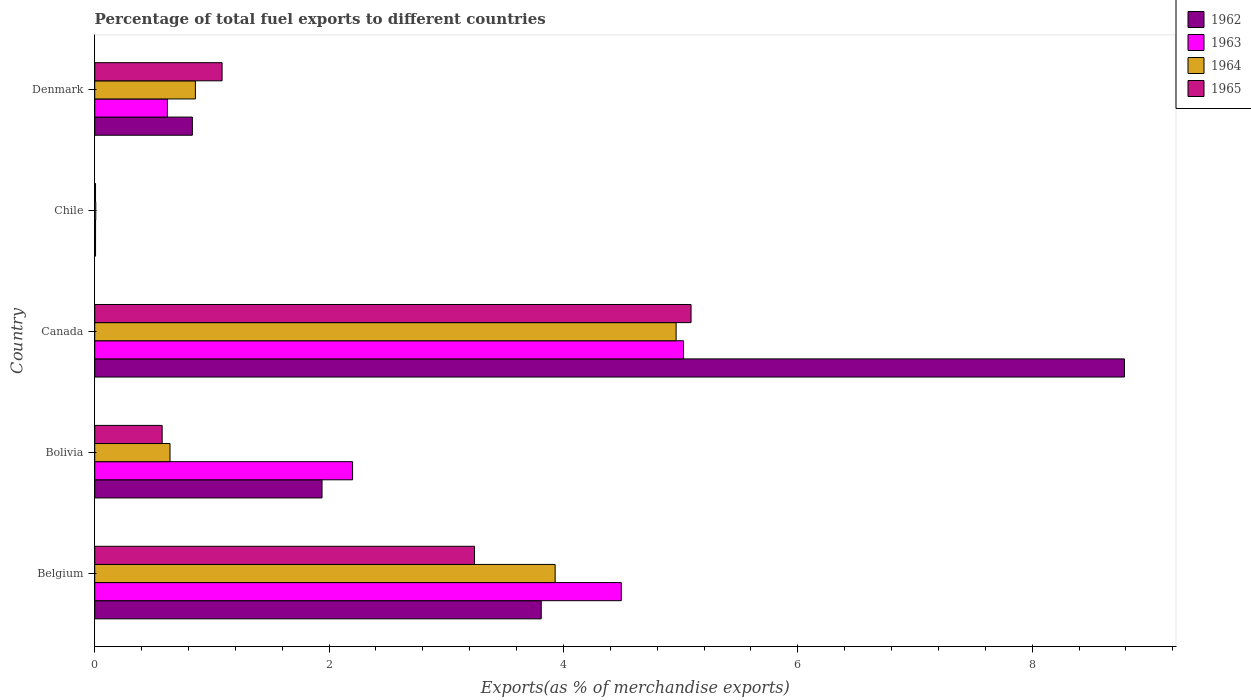How many bars are there on the 3rd tick from the bottom?
Provide a succinct answer. 4. What is the label of the 5th group of bars from the top?
Your answer should be compact. Belgium. What is the percentage of exports to different countries in 1963 in Canada?
Ensure brevity in your answer.  5.02. Across all countries, what is the maximum percentage of exports to different countries in 1964?
Give a very brief answer. 4.96. Across all countries, what is the minimum percentage of exports to different countries in 1965?
Offer a terse response. 0.01. In which country was the percentage of exports to different countries in 1962 maximum?
Offer a very short reply. Canada. In which country was the percentage of exports to different countries in 1964 minimum?
Ensure brevity in your answer.  Chile. What is the total percentage of exports to different countries in 1964 in the graph?
Your answer should be very brief. 10.4. What is the difference between the percentage of exports to different countries in 1962 in Chile and that in Denmark?
Offer a very short reply. -0.83. What is the difference between the percentage of exports to different countries in 1964 in Belgium and the percentage of exports to different countries in 1962 in Canada?
Provide a succinct answer. -4.86. What is the average percentage of exports to different countries in 1965 per country?
Your answer should be compact. 2. What is the difference between the percentage of exports to different countries in 1964 and percentage of exports to different countries in 1962 in Canada?
Your answer should be compact. -3.83. In how many countries, is the percentage of exports to different countries in 1965 greater than 6 %?
Your response must be concise. 0. What is the ratio of the percentage of exports to different countries in 1964 in Bolivia to that in Chile?
Your answer should be compact. 71.92. Is the percentage of exports to different countries in 1963 in Belgium less than that in Chile?
Offer a terse response. No. Is the difference between the percentage of exports to different countries in 1964 in Canada and Chile greater than the difference between the percentage of exports to different countries in 1962 in Canada and Chile?
Your answer should be compact. No. What is the difference between the highest and the second highest percentage of exports to different countries in 1963?
Give a very brief answer. 0.53. What is the difference between the highest and the lowest percentage of exports to different countries in 1962?
Your answer should be very brief. 8.78. In how many countries, is the percentage of exports to different countries in 1963 greater than the average percentage of exports to different countries in 1963 taken over all countries?
Make the answer very short. 2. Is it the case that in every country, the sum of the percentage of exports to different countries in 1964 and percentage of exports to different countries in 1962 is greater than the sum of percentage of exports to different countries in 1963 and percentage of exports to different countries in 1965?
Provide a succinct answer. No. What does the 3rd bar from the top in Belgium represents?
Keep it short and to the point. 1963. What does the 3rd bar from the bottom in Chile represents?
Provide a succinct answer. 1964. How many bars are there?
Your answer should be compact. 20. How many countries are there in the graph?
Your answer should be very brief. 5. What is the difference between two consecutive major ticks on the X-axis?
Offer a very short reply. 2. Does the graph contain any zero values?
Offer a terse response. No. Does the graph contain grids?
Offer a very short reply. No. Where does the legend appear in the graph?
Ensure brevity in your answer.  Top right. How many legend labels are there?
Offer a very short reply. 4. What is the title of the graph?
Make the answer very short. Percentage of total fuel exports to different countries. Does "1995" appear as one of the legend labels in the graph?
Your answer should be compact. No. What is the label or title of the X-axis?
Provide a succinct answer. Exports(as % of merchandise exports). What is the label or title of the Y-axis?
Your answer should be very brief. Country. What is the Exports(as % of merchandise exports) in 1962 in Belgium?
Ensure brevity in your answer.  3.81. What is the Exports(as % of merchandise exports) in 1963 in Belgium?
Your answer should be very brief. 4.49. What is the Exports(as % of merchandise exports) of 1964 in Belgium?
Keep it short and to the point. 3.93. What is the Exports(as % of merchandise exports) of 1965 in Belgium?
Your response must be concise. 3.24. What is the Exports(as % of merchandise exports) of 1962 in Bolivia?
Provide a succinct answer. 1.94. What is the Exports(as % of merchandise exports) of 1963 in Bolivia?
Offer a very short reply. 2.2. What is the Exports(as % of merchandise exports) of 1964 in Bolivia?
Provide a short and direct response. 0.64. What is the Exports(as % of merchandise exports) in 1965 in Bolivia?
Provide a short and direct response. 0.58. What is the Exports(as % of merchandise exports) of 1962 in Canada?
Your answer should be compact. 8.79. What is the Exports(as % of merchandise exports) of 1963 in Canada?
Make the answer very short. 5.02. What is the Exports(as % of merchandise exports) of 1964 in Canada?
Give a very brief answer. 4.96. What is the Exports(as % of merchandise exports) of 1965 in Canada?
Give a very brief answer. 5.09. What is the Exports(as % of merchandise exports) in 1962 in Chile?
Your answer should be compact. 0.01. What is the Exports(as % of merchandise exports) of 1963 in Chile?
Keep it short and to the point. 0.01. What is the Exports(as % of merchandise exports) of 1964 in Chile?
Give a very brief answer. 0.01. What is the Exports(as % of merchandise exports) of 1965 in Chile?
Your answer should be compact. 0.01. What is the Exports(as % of merchandise exports) of 1962 in Denmark?
Your answer should be compact. 0.83. What is the Exports(as % of merchandise exports) in 1963 in Denmark?
Offer a very short reply. 0.62. What is the Exports(as % of merchandise exports) of 1964 in Denmark?
Your answer should be compact. 0.86. What is the Exports(as % of merchandise exports) in 1965 in Denmark?
Your response must be concise. 1.09. Across all countries, what is the maximum Exports(as % of merchandise exports) of 1962?
Make the answer very short. 8.79. Across all countries, what is the maximum Exports(as % of merchandise exports) in 1963?
Your answer should be compact. 5.02. Across all countries, what is the maximum Exports(as % of merchandise exports) in 1964?
Your answer should be compact. 4.96. Across all countries, what is the maximum Exports(as % of merchandise exports) of 1965?
Make the answer very short. 5.09. Across all countries, what is the minimum Exports(as % of merchandise exports) of 1962?
Provide a short and direct response. 0.01. Across all countries, what is the minimum Exports(as % of merchandise exports) in 1963?
Make the answer very short. 0.01. Across all countries, what is the minimum Exports(as % of merchandise exports) of 1964?
Provide a succinct answer. 0.01. Across all countries, what is the minimum Exports(as % of merchandise exports) in 1965?
Your response must be concise. 0.01. What is the total Exports(as % of merchandise exports) of 1962 in the graph?
Offer a very short reply. 15.38. What is the total Exports(as % of merchandise exports) in 1963 in the graph?
Give a very brief answer. 12.35. What is the total Exports(as % of merchandise exports) of 1964 in the graph?
Keep it short and to the point. 10.4. What is the total Exports(as % of merchandise exports) of 1965 in the graph?
Make the answer very short. 10. What is the difference between the Exports(as % of merchandise exports) of 1962 in Belgium and that in Bolivia?
Give a very brief answer. 1.87. What is the difference between the Exports(as % of merchandise exports) of 1963 in Belgium and that in Bolivia?
Ensure brevity in your answer.  2.29. What is the difference between the Exports(as % of merchandise exports) of 1964 in Belgium and that in Bolivia?
Make the answer very short. 3.29. What is the difference between the Exports(as % of merchandise exports) of 1965 in Belgium and that in Bolivia?
Your response must be concise. 2.67. What is the difference between the Exports(as % of merchandise exports) in 1962 in Belgium and that in Canada?
Offer a terse response. -4.98. What is the difference between the Exports(as % of merchandise exports) in 1963 in Belgium and that in Canada?
Your answer should be compact. -0.53. What is the difference between the Exports(as % of merchandise exports) in 1964 in Belgium and that in Canada?
Offer a terse response. -1.03. What is the difference between the Exports(as % of merchandise exports) of 1965 in Belgium and that in Canada?
Keep it short and to the point. -1.85. What is the difference between the Exports(as % of merchandise exports) of 1962 in Belgium and that in Chile?
Give a very brief answer. 3.8. What is the difference between the Exports(as % of merchandise exports) of 1963 in Belgium and that in Chile?
Your answer should be compact. 4.49. What is the difference between the Exports(as % of merchandise exports) in 1964 in Belgium and that in Chile?
Ensure brevity in your answer.  3.92. What is the difference between the Exports(as % of merchandise exports) in 1965 in Belgium and that in Chile?
Make the answer very short. 3.23. What is the difference between the Exports(as % of merchandise exports) in 1962 in Belgium and that in Denmark?
Keep it short and to the point. 2.98. What is the difference between the Exports(as % of merchandise exports) in 1963 in Belgium and that in Denmark?
Keep it short and to the point. 3.87. What is the difference between the Exports(as % of merchandise exports) of 1964 in Belgium and that in Denmark?
Ensure brevity in your answer.  3.07. What is the difference between the Exports(as % of merchandise exports) in 1965 in Belgium and that in Denmark?
Give a very brief answer. 2.15. What is the difference between the Exports(as % of merchandise exports) of 1962 in Bolivia and that in Canada?
Your response must be concise. -6.85. What is the difference between the Exports(as % of merchandise exports) in 1963 in Bolivia and that in Canada?
Your answer should be compact. -2.82. What is the difference between the Exports(as % of merchandise exports) of 1964 in Bolivia and that in Canada?
Give a very brief answer. -4.32. What is the difference between the Exports(as % of merchandise exports) in 1965 in Bolivia and that in Canada?
Your answer should be very brief. -4.51. What is the difference between the Exports(as % of merchandise exports) of 1962 in Bolivia and that in Chile?
Ensure brevity in your answer.  1.93. What is the difference between the Exports(as % of merchandise exports) of 1963 in Bolivia and that in Chile?
Make the answer very short. 2.19. What is the difference between the Exports(as % of merchandise exports) in 1964 in Bolivia and that in Chile?
Offer a terse response. 0.63. What is the difference between the Exports(as % of merchandise exports) in 1965 in Bolivia and that in Chile?
Give a very brief answer. 0.57. What is the difference between the Exports(as % of merchandise exports) in 1962 in Bolivia and that in Denmark?
Ensure brevity in your answer.  1.11. What is the difference between the Exports(as % of merchandise exports) in 1963 in Bolivia and that in Denmark?
Your answer should be very brief. 1.58. What is the difference between the Exports(as % of merchandise exports) of 1964 in Bolivia and that in Denmark?
Provide a short and direct response. -0.22. What is the difference between the Exports(as % of merchandise exports) in 1965 in Bolivia and that in Denmark?
Offer a very short reply. -0.51. What is the difference between the Exports(as % of merchandise exports) in 1962 in Canada and that in Chile?
Your answer should be very brief. 8.78. What is the difference between the Exports(as % of merchandise exports) in 1963 in Canada and that in Chile?
Provide a short and direct response. 5.02. What is the difference between the Exports(as % of merchandise exports) in 1964 in Canada and that in Chile?
Ensure brevity in your answer.  4.95. What is the difference between the Exports(as % of merchandise exports) of 1965 in Canada and that in Chile?
Your answer should be compact. 5.08. What is the difference between the Exports(as % of merchandise exports) of 1962 in Canada and that in Denmark?
Make the answer very short. 7.95. What is the difference between the Exports(as % of merchandise exports) in 1963 in Canada and that in Denmark?
Give a very brief answer. 4.4. What is the difference between the Exports(as % of merchandise exports) of 1964 in Canada and that in Denmark?
Keep it short and to the point. 4.1. What is the difference between the Exports(as % of merchandise exports) in 1965 in Canada and that in Denmark?
Provide a short and direct response. 4. What is the difference between the Exports(as % of merchandise exports) in 1962 in Chile and that in Denmark?
Ensure brevity in your answer.  -0.83. What is the difference between the Exports(as % of merchandise exports) in 1963 in Chile and that in Denmark?
Your answer should be very brief. -0.61. What is the difference between the Exports(as % of merchandise exports) in 1964 in Chile and that in Denmark?
Keep it short and to the point. -0.85. What is the difference between the Exports(as % of merchandise exports) of 1965 in Chile and that in Denmark?
Offer a very short reply. -1.08. What is the difference between the Exports(as % of merchandise exports) of 1962 in Belgium and the Exports(as % of merchandise exports) of 1963 in Bolivia?
Your answer should be very brief. 1.61. What is the difference between the Exports(as % of merchandise exports) of 1962 in Belgium and the Exports(as % of merchandise exports) of 1964 in Bolivia?
Provide a short and direct response. 3.17. What is the difference between the Exports(as % of merchandise exports) of 1962 in Belgium and the Exports(as % of merchandise exports) of 1965 in Bolivia?
Your answer should be very brief. 3.23. What is the difference between the Exports(as % of merchandise exports) in 1963 in Belgium and the Exports(as % of merchandise exports) in 1964 in Bolivia?
Your answer should be very brief. 3.85. What is the difference between the Exports(as % of merchandise exports) in 1963 in Belgium and the Exports(as % of merchandise exports) in 1965 in Bolivia?
Provide a succinct answer. 3.92. What is the difference between the Exports(as % of merchandise exports) of 1964 in Belgium and the Exports(as % of merchandise exports) of 1965 in Bolivia?
Your answer should be very brief. 3.35. What is the difference between the Exports(as % of merchandise exports) in 1962 in Belgium and the Exports(as % of merchandise exports) in 1963 in Canada?
Ensure brevity in your answer.  -1.21. What is the difference between the Exports(as % of merchandise exports) of 1962 in Belgium and the Exports(as % of merchandise exports) of 1964 in Canada?
Keep it short and to the point. -1.15. What is the difference between the Exports(as % of merchandise exports) in 1962 in Belgium and the Exports(as % of merchandise exports) in 1965 in Canada?
Ensure brevity in your answer.  -1.28. What is the difference between the Exports(as % of merchandise exports) in 1963 in Belgium and the Exports(as % of merchandise exports) in 1964 in Canada?
Provide a succinct answer. -0.47. What is the difference between the Exports(as % of merchandise exports) in 1963 in Belgium and the Exports(as % of merchandise exports) in 1965 in Canada?
Your response must be concise. -0.6. What is the difference between the Exports(as % of merchandise exports) of 1964 in Belgium and the Exports(as % of merchandise exports) of 1965 in Canada?
Your answer should be very brief. -1.16. What is the difference between the Exports(as % of merchandise exports) of 1962 in Belgium and the Exports(as % of merchandise exports) of 1963 in Chile?
Provide a succinct answer. 3.8. What is the difference between the Exports(as % of merchandise exports) in 1962 in Belgium and the Exports(as % of merchandise exports) in 1964 in Chile?
Make the answer very short. 3.8. What is the difference between the Exports(as % of merchandise exports) of 1962 in Belgium and the Exports(as % of merchandise exports) of 1965 in Chile?
Keep it short and to the point. 3.8. What is the difference between the Exports(as % of merchandise exports) in 1963 in Belgium and the Exports(as % of merchandise exports) in 1964 in Chile?
Offer a very short reply. 4.48. What is the difference between the Exports(as % of merchandise exports) in 1963 in Belgium and the Exports(as % of merchandise exports) in 1965 in Chile?
Your response must be concise. 4.49. What is the difference between the Exports(as % of merchandise exports) in 1964 in Belgium and the Exports(as % of merchandise exports) in 1965 in Chile?
Make the answer very short. 3.92. What is the difference between the Exports(as % of merchandise exports) in 1962 in Belgium and the Exports(as % of merchandise exports) in 1963 in Denmark?
Your answer should be very brief. 3.19. What is the difference between the Exports(as % of merchandise exports) of 1962 in Belgium and the Exports(as % of merchandise exports) of 1964 in Denmark?
Provide a succinct answer. 2.95. What is the difference between the Exports(as % of merchandise exports) of 1962 in Belgium and the Exports(as % of merchandise exports) of 1965 in Denmark?
Your response must be concise. 2.72. What is the difference between the Exports(as % of merchandise exports) in 1963 in Belgium and the Exports(as % of merchandise exports) in 1964 in Denmark?
Ensure brevity in your answer.  3.63. What is the difference between the Exports(as % of merchandise exports) of 1963 in Belgium and the Exports(as % of merchandise exports) of 1965 in Denmark?
Give a very brief answer. 3.41. What is the difference between the Exports(as % of merchandise exports) of 1964 in Belgium and the Exports(as % of merchandise exports) of 1965 in Denmark?
Give a very brief answer. 2.84. What is the difference between the Exports(as % of merchandise exports) of 1962 in Bolivia and the Exports(as % of merchandise exports) of 1963 in Canada?
Give a very brief answer. -3.08. What is the difference between the Exports(as % of merchandise exports) of 1962 in Bolivia and the Exports(as % of merchandise exports) of 1964 in Canada?
Your answer should be compact. -3.02. What is the difference between the Exports(as % of merchandise exports) of 1962 in Bolivia and the Exports(as % of merchandise exports) of 1965 in Canada?
Ensure brevity in your answer.  -3.15. What is the difference between the Exports(as % of merchandise exports) of 1963 in Bolivia and the Exports(as % of merchandise exports) of 1964 in Canada?
Make the answer very short. -2.76. What is the difference between the Exports(as % of merchandise exports) of 1963 in Bolivia and the Exports(as % of merchandise exports) of 1965 in Canada?
Your answer should be very brief. -2.89. What is the difference between the Exports(as % of merchandise exports) in 1964 in Bolivia and the Exports(as % of merchandise exports) in 1965 in Canada?
Your response must be concise. -4.45. What is the difference between the Exports(as % of merchandise exports) of 1962 in Bolivia and the Exports(as % of merchandise exports) of 1963 in Chile?
Make the answer very short. 1.93. What is the difference between the Exports(as % of merchandise exports) in 1962 in Bolivia and the Exports(as % of merchandise exports) in 1964 in Chile?
Offer a very short reply. 1.93. What is the difference between the Exports(as % of merchandise exports) in 1962 in Bolivia and the Exports(as % of merchandise exports) in 1965 in Chile?
Make the answer very short. 1.93. What is the difference between the Exports(as % of merchandise exports) in 1963 in Bolivia and the Exports(as % of merchandise exports) in 1964 in Chile?
Your answer should be compact. 2.19. What is the difference between the Exports(as % of merchandise exports) in 1963 in Bolivia and the Exports(as % of merchandise exports) in 1965 in Chile?
Ensure brevity in your answer.  2.19. What is the difference between the Exports(as % of merchandise exports) in 1964 in Bolivia and the Exports(as % of merchandise exports) in 1965 in Chile?
Keep it short and to the point. 0.64. What is the difference between the Exports(as % of merchandise exports) in 1962 in Bolivia and the Exports(as % of merchandise exports) in 1963 in Denmark?
Offer a very short reply. 1.32. What is the difference between the Exports(as % of merchandise exports) of 1962 in Bolivia and the Exports(as % of merchandise exports) of 1964 in Denmark?
Your answer should be very brief. 1.08. What is the difference between the Exports(as % of merchandise exports) in 1962 in Bolivia and the Exports(as % of merchandise exports) in 1965 in Denmark?
Keep it short and to the point. 0.85. What is the difference between the Exports(as % of merchandise exports) of 1963 in Bolivia and the Exports(as % of merchandise exports) of 1964 in Denmark?
Provide a succinct answer. 1.34. What is the difference between the Exports(as % of merchandise exports) of 1963 in Bolivia and the Exports(as % of merchandise exports) of 1965 in Denmark?
Make the answer very short. 1.11. What is the difference between the Exports(as % of merchandise exports) in 1964 in Bolivia and the Exports(as % of merchandise exports) in 1965 in Denmark?
Your response must be concise. -0.44. What is the difference between the Exports(as % of merchandise exports) in 1962 in Canada and the Exports(as % of merchandise exports) in 1963 in Chile?
Give a very brief answer. 8.78. What is the difference between the Exports(as % of merchandise exports) in 1962 in Canada and the Exports(as % of merchandise exports) in 1964 in Chile?
Your answer should be compact. 8.78. What is the difference between the Exports(as % of merchandise exports) of 1962 in Canada and the Exports(as % of merchandise exports) of 1965 in Chile?
Offer a very short reply. 8.78. What is the difference between the Exports(as % of merchandise exports) in 1963 in Canada and the Exports(as % of merchandise exports) in 1964 in Chile?
Your answer should be compact. 5.02. What is the difference between the Exports(as % of merchandise exports) in 1963 in Canada and the Exports(as % of merchandise exports) in 1965 in Chile?
Provide a succinct answer. 5.02. What is the difference between the Exports(as % of merchandise exports) in 1964 in Canada and the Exports(as % of merchandise exports) in 1965 in Chile?
Keep it short and to the point. 4.95. What is the difference between the Exports(as % of merchandise exports) in 1962 in Canada and the Exports(as % of merchandise exports) in 1963 in Denmark?
Give a very brief answer. 8.17. What is the difference between the Exports(as % of merchandise exports) of 1962 in Canada and the Exports(as % of merchandise exports) of 1964 in Denmark?
Ensure brevity in your answer.  7.93. What is the difference between the Exports(as % of merchandise exports) in 1962 in Canada and the Exports(as % of merchandise exports) in 1965 in Denmark?
Your answer should be compact. 7.7. What is the difference between the Exports(as % of merchandise exports) in 1963 in Canada and the Exports(as % of merchandise exports) in 1964 in Denmark?
Your answer should be very brief. 4.17. What is the difference between the Exports(as % of merchandise exports) of 1963 in Canada and the Exports(as % of merchandise exports) of 1965 in Denmark?
Offer a terse response. 3.94. What is the difference between the Exports(as % of merchandise exports) in 1964 in Canada and the Exports(as % of merchandise exports) in 1965 in Denmark?
Offer a very short reply. 3.87. What is the difference between the Exports(as % of merchandise exports) in 1962 in Chile and the Exports(as % of merchandise exports) in 1963 in Denmark?
Ensure brevity in your answer.  -0.61. What is the difference between the Exports(as % of merchandise exports) in 1962 in Chile and the Exports(as % of merchandise exports) in 1964 in Denmark?
Offer a terse response. -0.85. What is the difference between the Exports(as % of merchandise exports) in 1962 in Chile and the Exports(as % of merchandise exports) in 1965 in Denmark?
Keep it short and to the point. -1.08. What is the difference between the Exports(as % of merchandise exports) in 1963 in Chile and the Exports(as % of merchandise exports) in 1964 in Denmark?
Your answer should be very brief. -0.85. What is the difference between the Exports(as % of merchandise exports) of 1963 in Chile and the Exports(as % of merchandise exports) of 1965 in Denmark?
Keep it short and to the point. -1.08. What is the difference between the Exports(as % of merchandise exports) in 1964 in Chile and the Exports(as % of merchandise exports) in 1965 in Denmark?
Offer a terse response. -1.08. What is the average Exports(as % of merchandise exports) of 1962 per country?
Your answer should be compact. 3.08. What is the average Exports(as % of merchandise exports) in 1963 per country?
Provide a short and direct response. 2.47. What is the average Exports(as % of merchandise exports) of 1964 per country?
Provide a succinct answer. 2.08. What is the average Exports(as % of merchandise exports) in 1965 per country?
Keep it short and to the point. 2. What is the difference between the Exports(as % of merchandise exports) of 1962 and Exports(as % of merchandise exports) of 1963 in Belgium?
Give a very brief answer. -0.68. What is the difference between the Exports(as % of merchandise exports) in 1962 and Exports(as % of merchandise exports) in 1964 in Belgium?
Give a very brief answer. -0.12. What is the difference between the Exports(as % of merchandise exports) of 1962 and Exports(as % of merchandise exports) of 1965 in Belgium?
Your response must be concise. 0.57. What is the difference between the Exports(as % of merchandise exports) of 1963 and Exports(as % of merchandise exports) of 1964 in Belgium?
Give a very brief answer. 0.56. What is the difference between the Exports(as % of merchandise exports) of 1963 and Exports(as % of merchandise exports) of 1965 in Belgium?
Ensure brevity in your answer.  1.25. What is the difference between the Exports(as % of merchandise exports) in 1964 and Exports(as % of merchandise exports) in 1965 in Belgium?
Provide a short and direct response. 0.69. What is the difference between the Exports(as % of merchandise exports) of 1962 and Exports(as % of merchandise exports) of 1963 in Bolivia?
Make the answer very short. -0.26. What is the difference between the Exports(as % of merchandise exports) in 1962 and Exports(as % of merchandise exports) in 1964 in Bolivia?
Offer a terse response. 1.3. What is the difference between the Exports(as % of merchandise exports) of 1962 and Exports(as % of merchandise exports) of 1965 in Bolivia?
Provide a short and direct response. 1.36. What is the difference between the Exports(as % of merchandise exports) in 1963 and Exports(as % of merchandise exports) in 1964 in Bolivia?
Provide a succinct answer. 1.56. What is the difference between the Exports(as % of merchandise exports) in 1963 and Exports(as % of merchandise exports) in 1965 in Bolivia?
Your response must be concise. 1.62. What is the difference between the Exports(as % of merchandise exports) of 1964 and Exports(as % of merchandise exports) of 1965 in Bolivia?
Your answer should be very brief. 0.07. What is the difference between the Exports(as % of merchandise exports) in 1962 and Exports(as % of merchandise exports) in 1963 in Canada?
Provide a short and direct response. 3.76. What is the difference between the Exports(as % of merchandise exports) in 1962 and Exports(as % of merchandise exports) in 1964 in Canada?
Offer a terse response. 3.83. What is the difference between the Exports(as % of merchandise exports) in 1962 and Exports(as % of merchandise exports) in 1965 in Canada?
Your answer should be compact. 3.7. What is the difference between the Exports(as % of merchandise exports) in 1963 and Exports(as % of merchandise exports) in 1964 in Canada?
Provide a succinct answer. 0.06. What is the difference between the Exports(as % of merchandise exports) in 1963 and Exports(as % of merchandise exports) in 1965 in Canada?
Your answer should be very brief. -0.06. What is the difference between the Exports(as % of merchandise exports) of 1964 and Exports(as % of merchandise exports) of 1965 in Canada?
Your answer should be very brief. -0.13. What is the difference between the Exports(as % of merchandise exports) of 1962 and Exports(as % of merchandise exports) of 1963 in Chile?
Provide a succinct answer. -0. What is the difference between the Exports(as % of merchandise exports) of 1962 and Exports(as % of merchandise exports) of 1964 in Chile?
Ensure brevity in your answer.  -0. What is the difference between the Exports(as % of merchandise exports) of 1963 and Exports(as % of merchandise exports) of 1964 in Chile?
Keep it short and to the point. -0. What is the difference between the Exports(as % of merchandise exports) of 1963 and Exports(as % of merchandise exports) of 1965 in Chile?
Keep it short and to the point. 0. What is the difference between the Exports(as % of merchandise exports) of 1964 and Exports(as % of merchandise exports) of 1965 in Chile?
Your response must be concise. 0. What is the difference between the Exports(as % of merchandise exports) of 1962 and Exports(as % of merchandise exports) of 1963 in Denmark?
Provide a short and direct response. 0.21. What is the difference between the Exports(as % of merchandise exports) of 1962 and Exports(as % of merchandise exports) of 1964 in Denmark?
Your answer should be compact. -0.03. What is the difference between the Exports(as % of merchandise exports) in 1962 and Exports(as % of merchandise exports) in 1965 in Denmark?
Make the answer very short. -0.25. What is the difference between the Exports(as % of merchandise exports) in 1963 and Exports(as % of merchandise exports) in 1964 in Denmark?
Your answer should be very brief. -0.24. What is the difference between the Exports(as % of merchandise exports) in 1963 and Exports(as % of merchandise exports) in 1965 in Denmark?
Your response must be concise. -0.47. What is the difference between the Exports(as % of merchandise exports) in 1964 and Exports(as % of merchandise exports) in 1965 in Denmark?
Offer a terse response. -0.23. What is the ratio of the Exports(as % of merchandise exports) of 1962 in Belgium to that in Bolivia?
Offer a very short reply. 1.96. What is the ratio of the Exports(as % of merchandise exports) in 1963 in Belgium to that in Bolivia?
Your answer should be compact. 2.04. What is the ratio of the Exports(as % of merchandise exports) in 1964 in Belgium to that in Bolivia?
Provide a succinct answer. 6.12. What is the ratio of the Exports(as % of merchandise exports) in 1965 in Belgium to that in Bolivia?
Offer a very short reply. 5.63. What is the ratio of the Exports(as % of merchandise exports) in 1962 in Belgium to that in Canada?
Give a very brief answer. 0.43. What is the ratio of the Exports(as % of merchandise exports) of 1963 in Belgium to that in Canada?
Offer a terse response. 0.89. What is the ratio of the Exports(as % of merchandise exports) of 1964 in Belgium to that in Canada?
Offer a very short reply. 0.79. What is the ratio of the Exports(as % of merchandise exports) in 1965 in Belgium to that in Canada?
Provide a short and direct response. 0.64. What is the ratio of the Exports(as % of merchandise exports) in 1962 in Belgium to that in Chile?
Provide a short and direct response. 543.89. What is the ratio of the Exports(as % of merchandise exports) in 1963 in Belgium to that in Chile?
Your answer should be very brief. 634.23. What is the ratio of the Exports(as % of merchandise exports) of 1964 in Belgium to that in Chile?
Keep it short and to the point. 439.88. What is the ratio of the Exports(as % of merchandise exports) of 1965 in Belgium to that in Chile?
Your response must be concise. 479.5. What is the ratio of the Exports(as % of merchandise exports) in 1962 in Belgium to that in Denmark?
Provide a succinct answer. 4.57. What is the ratio of the Exports(as % of merchandise exports) in 1963 in Belgium to that in Denmark?
Offer a very short reply. 7.24. What is the ratio of the Exports(as % of merchandise exports) in 1964 in Belgium to that in Denmark?
Keep it short and to the point. 4.57. What is the ratio of the Exports(as % of merchandise exports) of 1965 in Belgium to that in Denmark?
Give a very brief answer. 2.98. What is the ratio of the Exports(as % of merchandise exports) of 1962 in Bolivia to that in Canada?
Make the answer very short. 0.22. What is the ratio of the Exports(as % of merchandise exports) of 1963 in Bolivia to that in Canada?
Offer a terse response. 0.44. What is the ratio of the Exports(as % of merchandise exports) of 1964 in Bolivia to that in Canada?
Ensure brevity in your answer.  0.13. What is the ratio of the Exports(as % of merchandise exports) in 1965 in Bolivia to that in Canada?
Provide a short and direct response. 0.11. What is the ratio of the Exports(as % of merchandise exports) of 1962 in Bolivia to that in Chile?
Make the answer very short. 276.87. What is the ratio of the Exports(as % of merchandise exports) of 1963 in Bolivia to that in Chile?
Your answer should be compact. 310.59. What is the ratio of the Exports(as % of merchandise exports) of 1964 in Bolivia to that in Chile?
Make the answer very short. 71.92. What is the ratio of the Exports(as % of merchandise exports) in 1965 in Bolivia to that in Chile?
Offer a terse response. 85.13. What is the ratio of the Exports(as % of merchandise exports) of 1962 in Bolivia to that in Denmark?
Provide a short and direct response. 2.33. What is the ratio of the Exports(as % of merchandise exports) in 1963 in Bolivia to that in Denmark?
Offer a terse response. 3.55. What is the ratio of the Exports(as % of merchandise exports) in 1964 in Bolivia to that in Denmark?
Your answer should be very brief. 0.75. What is the ratio of the Exports(as % of merchandise exports) in 1965 in Bolivia to that in Denmark?
Offer a very short reply. 0.53. What is the ratio of the Exports(as % of merchandise exports) in 1962 in Canada to that in Chile?
Your answer should be very brief. 1254.38. What is the ratio of the Exports(as % of merchandise exports) of 1963 in Canada to that in Chile?
Your answer should be compact. 709.22. What is the ratio of the Exports(as % of merchandise exports) of 1964 in Canada to that in Chile?
Give a very brief answer. 555.45. What is the ratio of the Exports(as % of merchandise exports) of 1965 in Canada to that in Chile?
Make the answer very short. 752.83. What is the ratio of the Exports(as % of merchandise exports) in 1962 in Canada to that in Denmark?
Give a very brief answer. 10.55. What is the ratio of the Exports(as % of merchandise exports) in 1963 in Canada to that in Denmark?
Provide a succinct answer. 8.1. What is the ratio of the Exports(as % of merchandise exports) in 1964 in Canada to that in Denmark?
Offer a terse response. 5.78. What is the ratio of the Exports(as % of merchandise exports) in 1965 in Canada to that in Denmark?
Provide a short and direct response. 4.68. What is the ratio of the Exports(as % of merchandise exports) in 1962 in Chile to that in Denmark?
Provide a succinct answer. 0.01. What is the ratio of the Exports(as % of merchandise exports) in 1963 in Chile to that in Denmark?
Your answer should be compact. 0.01. What is the ratio of the Exports(as % of merchandise exports) in 1964 in Chile to that in Denmark?
Give a very brief answer. 0.01. What is the ratio of the Exports(as % of merchandise exports) of 1965 in Chile to that in Denmark?
Your response must be concise. 0.01. What is the difference between the highest and the second highest Exports(as % of merchandise exports) of 1962?
Keep it short and to the point. 4.98. What is the difference between the highest and the second highest Exports(as % of merchandise exports) in 1963?
Offer a very short reply. 0.53. What is the difference between the highest and the second highest Exports(as % of merchandise exports) of 1964?
Ensure brevity in your answer.  1.03. What is the difference between the highest and the second highest Exports(as % of merchandise exports) of 1965?
Provide a succinct answer. 1.85. What is the difference between the highest and the lowest Exports(as % of merchandise exports) in 1962?
Make the answer very short. 8.78. What is the difference between the highest and the lowest Exports(as % of merchandise exports) in 1963?
Give a very brief answer. 5.02. What is the difference between the highest and the lowest Exports(as % of merchandise exports) of 1964?
Your response must be concise. 4.95. What is the difference between the highest and the lowest Exports(as % of merchandise exports) in 1965?
Provide a succinct answer. 5.08. 